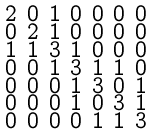<formula> <loc_0><loc_0><loc_500><loc_500>\begin{smallmatrix} 2 & 0 & 1 & 0 & 0 & 0 & 0 \\ 0 & 2 & 1 & 0 & 0 & 0 & 0 \\ 1 & 1 & 3 & 1 & 0 & 0 & 0 \\ 0 & 0 & 1 & 3 & 1 & 1 & 0 \\ 0 & 0 & 0 & 1 & 3 & 0 & 1 \\ 0 & 0 & 0 & 1 & 0 & 3 & 1 \\ 0 & 0 & 0 & 0 & 1 & 1 & 3 \end{smallmatrix}</formula> 